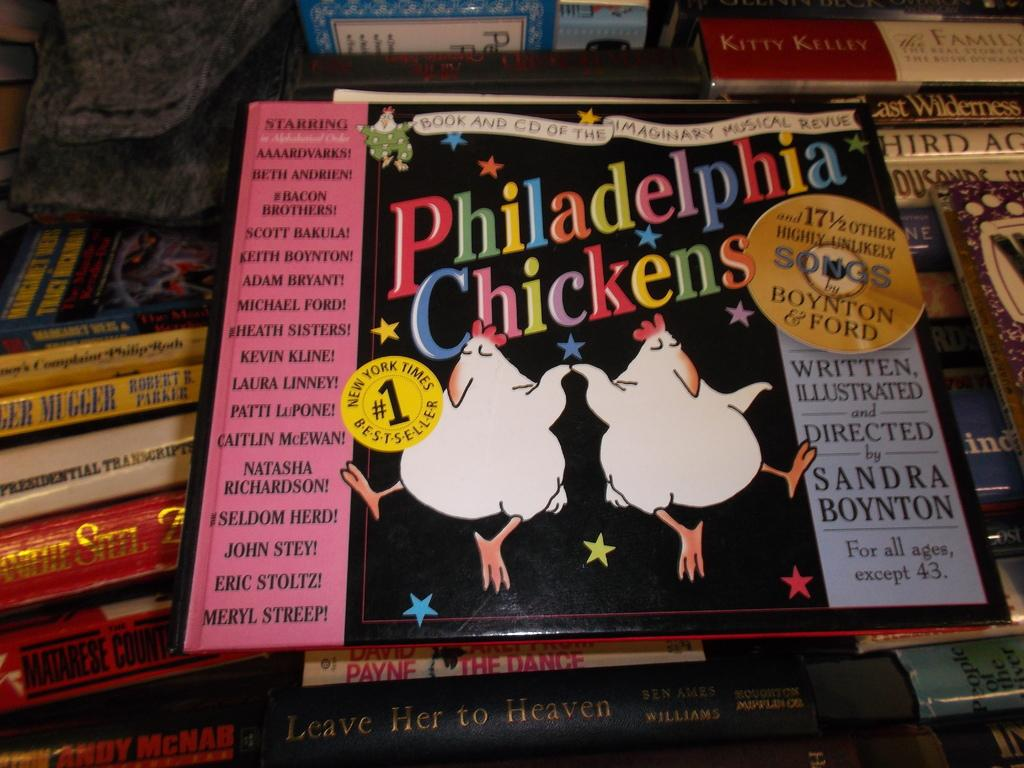<image>
Relay a brief, clear account of the picture shown. A music album called Philadelphia Chickens sits on a pile of books. 